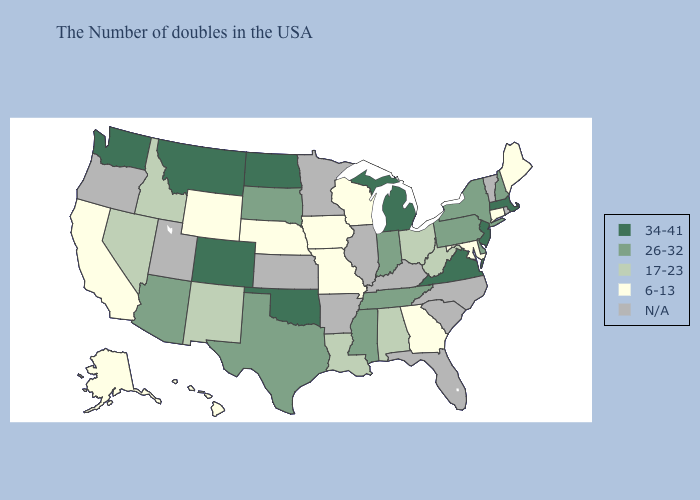What is the lowest value in the USA?
Be succinct. 6-13. What is the highest value in the Northeast ?
Give a very brief answer. 34-41. Name the states that have a value in the range 26-32?
Short answer required. New Hampshire, New York, Delaware, Pennsylvania, Indiana, Tennessee, Mississippi, Texas, South Dakota, Arizona. What is the lowest value in the Northeast?
Answer briefly. 6-13. How many symbols are there in the legend?
Quick response, please. 5. Which states have the lowest value in the USA?
Give a very brief answer. Maine, Connecticut, Maryland, Georgia, Wisconsin, Missouri, Iowa, Nebraska, Wyoming, California, Alaska, Hawaii. Which states have the lowest value in the USA?
Write a very short answer. Maine, Connecticut, Maryland, Georgia, Wisconsin, Missouri, Iowa, Nebraska, Wyoming, California, Alaska, Hawaii. What is the value of Mississippi?
Short answer required. 26-32. What is the value of Wyoming?
Short answer required. 6-13. What is the lowest value in the USA?
Be succinct. 6-13. Which states hav the highest value in the West?
Give a very brief answer. Colorado, Montana, Washington. Does the map have missing data?
Answer briefly. Yes. Among the states that border Texas , which have the highest value?
Give a very brief answer. Oklahoma. Which states hav the highest value in the South?
Quick response, please. Virginia, Oklahoma. Which states have the lowest value in the USA?
Concise answer only. Maine, Connecticut, Maryland, Georgia, Wisconsin, Missouri, Iowa, Nebraska, Wyoming, California, Alaska, Hawaii. 